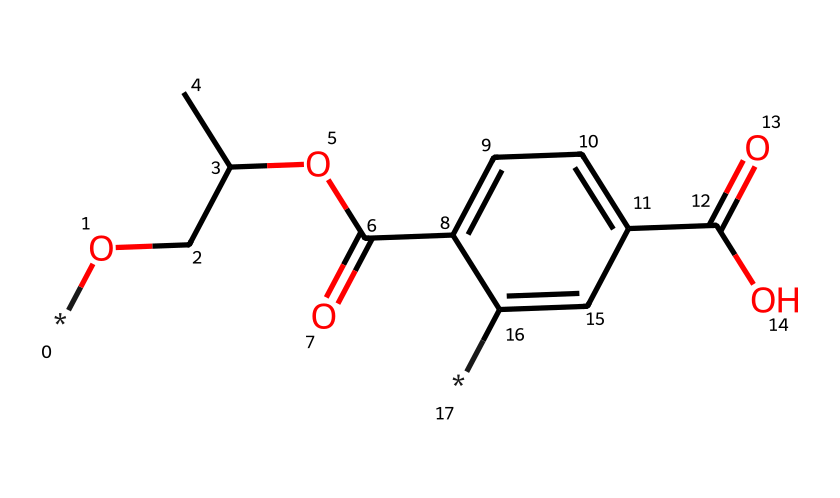What is the total number of carbon atoms in this chemical structure? The chemical structure can be broken down by counting each carbon atom in the SMILES representation. Upon inspection, we identify six carbon atoms in the aromatic ring and five in the aliphatic part, which totals eleven carbon atoms overall.
Answer: eleven How many oxygen atoms are present in this structure? In the given SMILES representation, we count each oxygen atom. There are three oxygen atoms visible, confirming their presence in the structure.
Answer: three Which functional groups are present in this chemical? Examining the SMILES representation, we notice the presence of carboxylic acid (from the -C(=O)O) and ester (from the -C(=O)OCC) functional groups. These are identified based on their characteristic arrangements of atoms.
Answer: carboxylic acid and ester What does the presence of the aromatic ring indicate about this fiber's properties? The presence of an aromatic ring typically suggests increased stability, resistance to degradation, and potential for color retention in the fibers. This structure contributes to properties important for eco-friendly textiles.
Answer: stability and color retention How might the polymerization of this chemical influence the streetwear production process? Polymerization involves linking individual monomers to create a long-chain polymer, making the fibers produced from this chemical structurally strong and versatile. This affects durability and flexibility during manufacturing, which are crucial for streetwear.
Answer: strength and versatility 